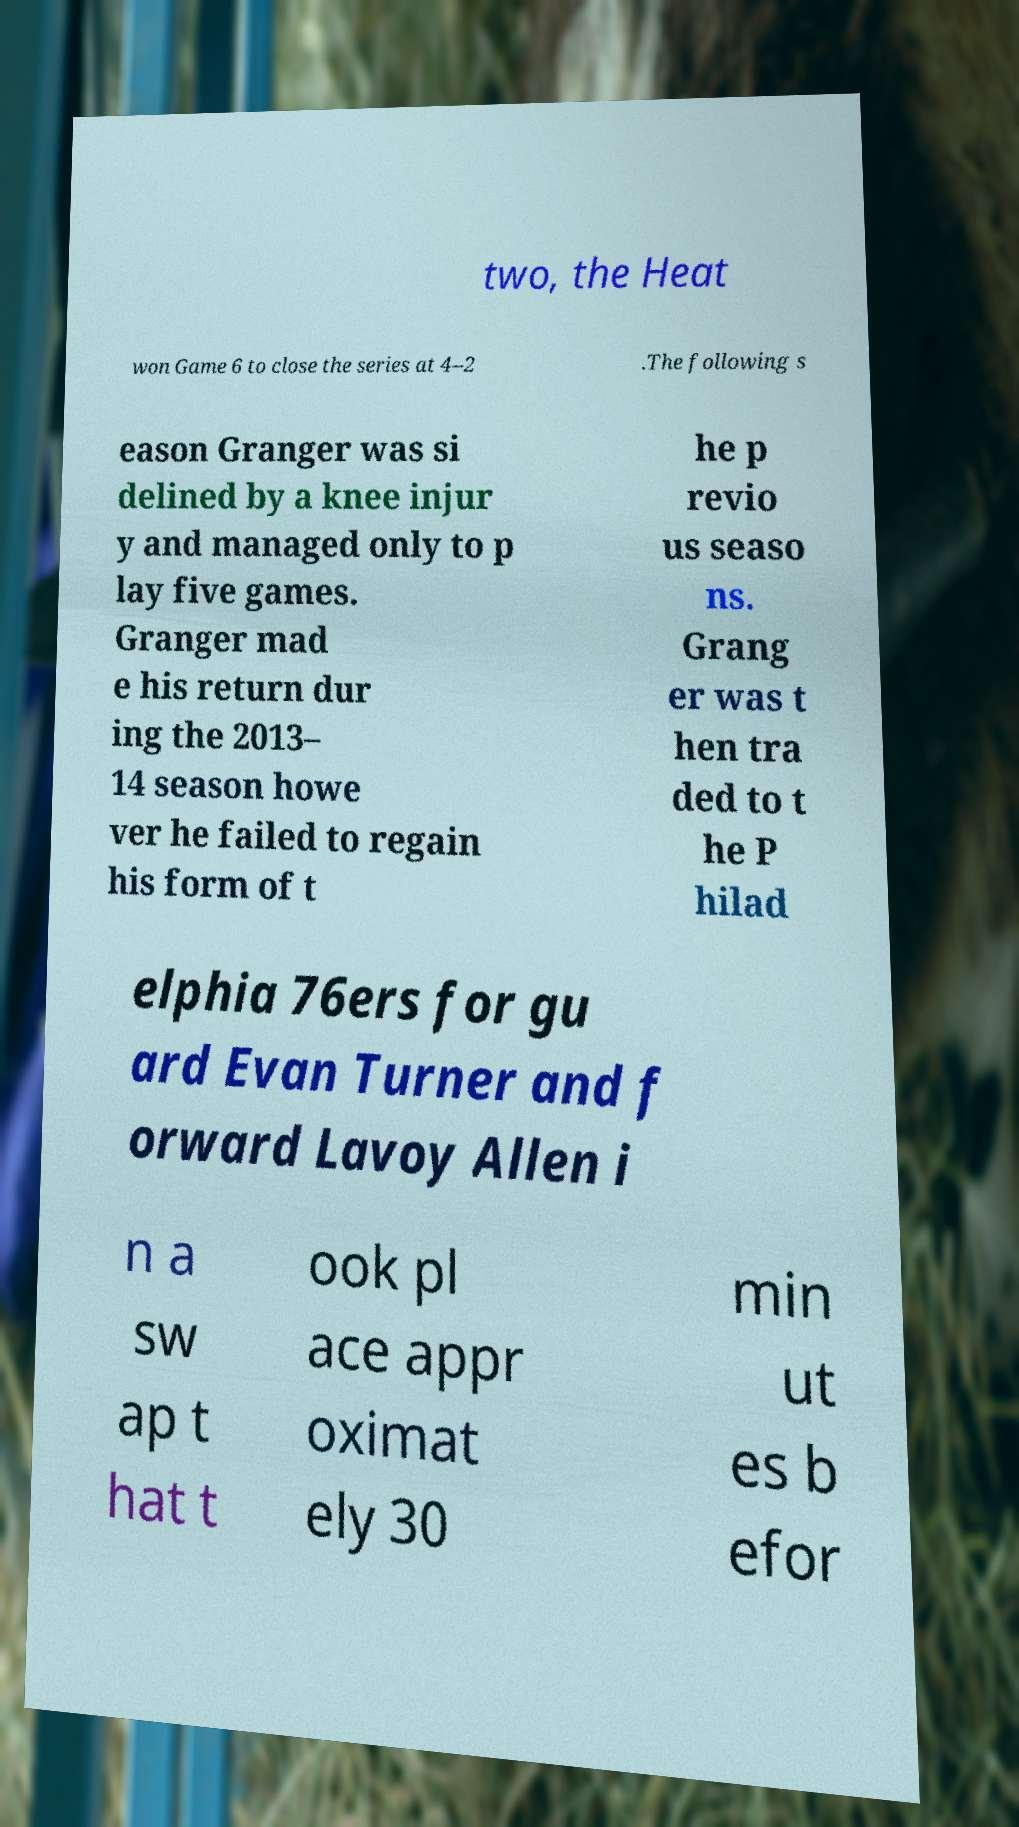Can you read and provide the text displayed in the image?This photo seems to have some interesting text. Can you extract and type it out for me? two, the Heat won Game 6 to close the series at 4–2 .The following s eason Granger was si delined by a knee injur y and managed only to p lay five games. Granger mad e his return dur ing the 2013– 14 season howe ver he failed to regain his form of t he p revio us seaso ns. Grang er was t hen tra ded to t he P hilad elphia 76ers for gu ard Evan Turner and f orward Lavoy Allen i n a sw ap t hat t ook pl ace appr oximat ely 30 min ut es b efor 